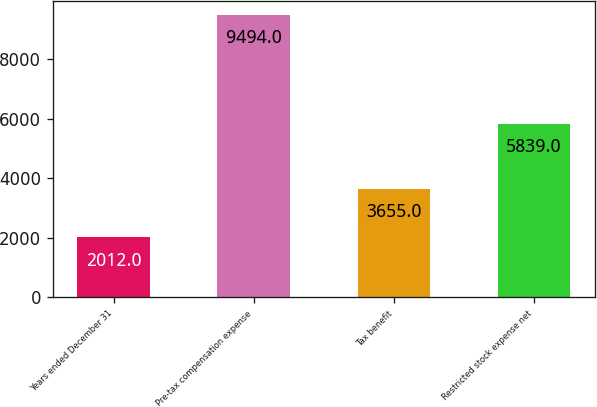<chart> <loc_0><loc_0><loc_500><loc_500><bar_chart><fcel>Years ended December 31<fcel>Pre-tax compensation expense<fcel>Tax benefit<fcel>Restricted stock expense net<nl><fcel>2012<fcel>9494<fcel>3655<fcel>5839<nl></chart> 